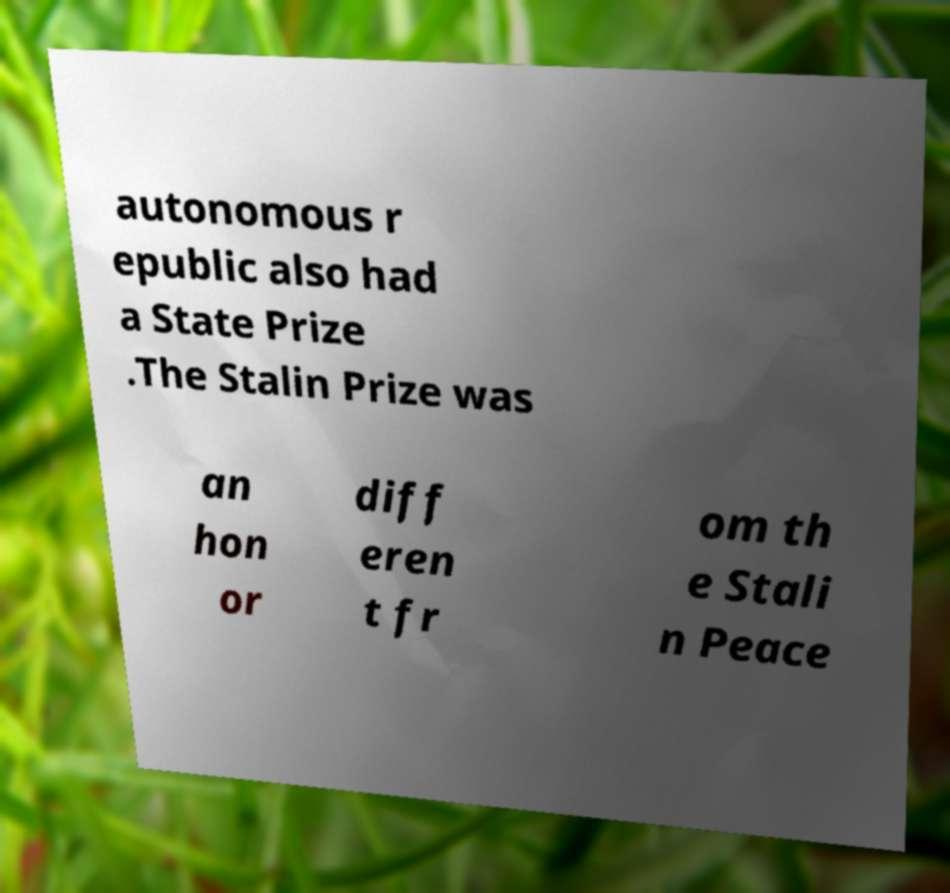Could you assist in decoding the text presented in this image and type it out clearly? autonomous r epublic also had a State Prize .The Stalin Prize was an hon or diff eren t fr om th e Stali n Peace 